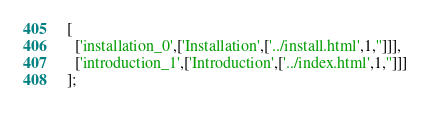<code> <loc_0><loc_0><loc_500><loc_500><_JavaScript_>[
  ['installation_0',['Installation',['../install.html',1,'']]],
  ['introduction_1',['Introduction',['../index.html',1,'']]]
];
</code> 